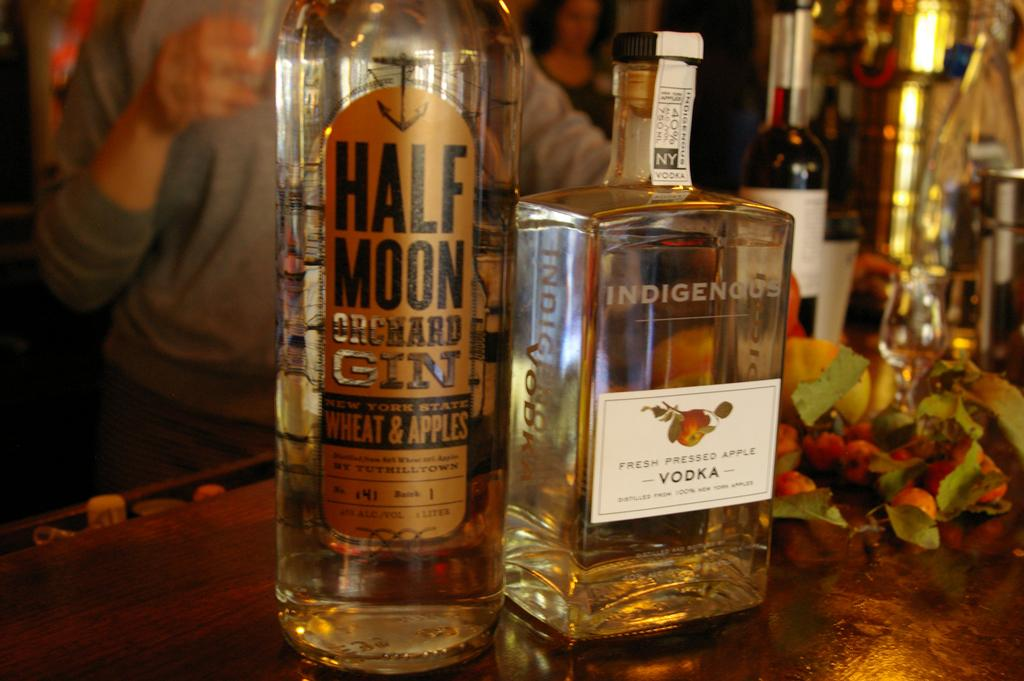<image>
Relay a brief, clear account of the picture shown. two bottles of liquor on a bar and one is called Half Moon Orchard Gin 